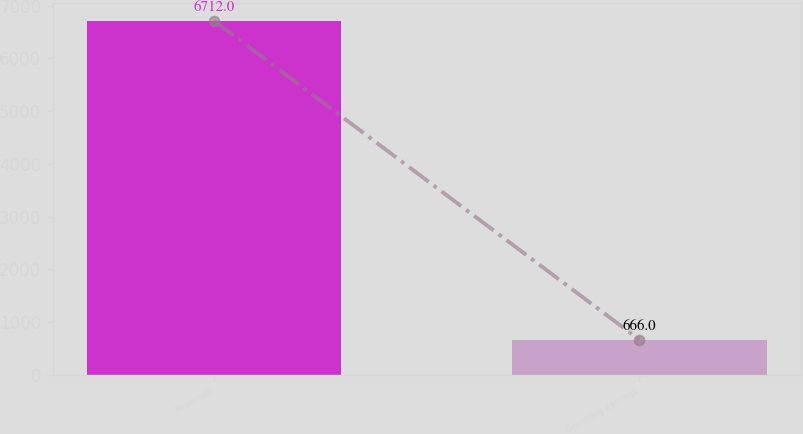Convert chart. <chart><loc_0><loc_0><loc_500><loc_500><bar_chart><fcel>Revenues<fcel>Operating earnings<nl><fcel>6712<fcel>666<nl></chart> 